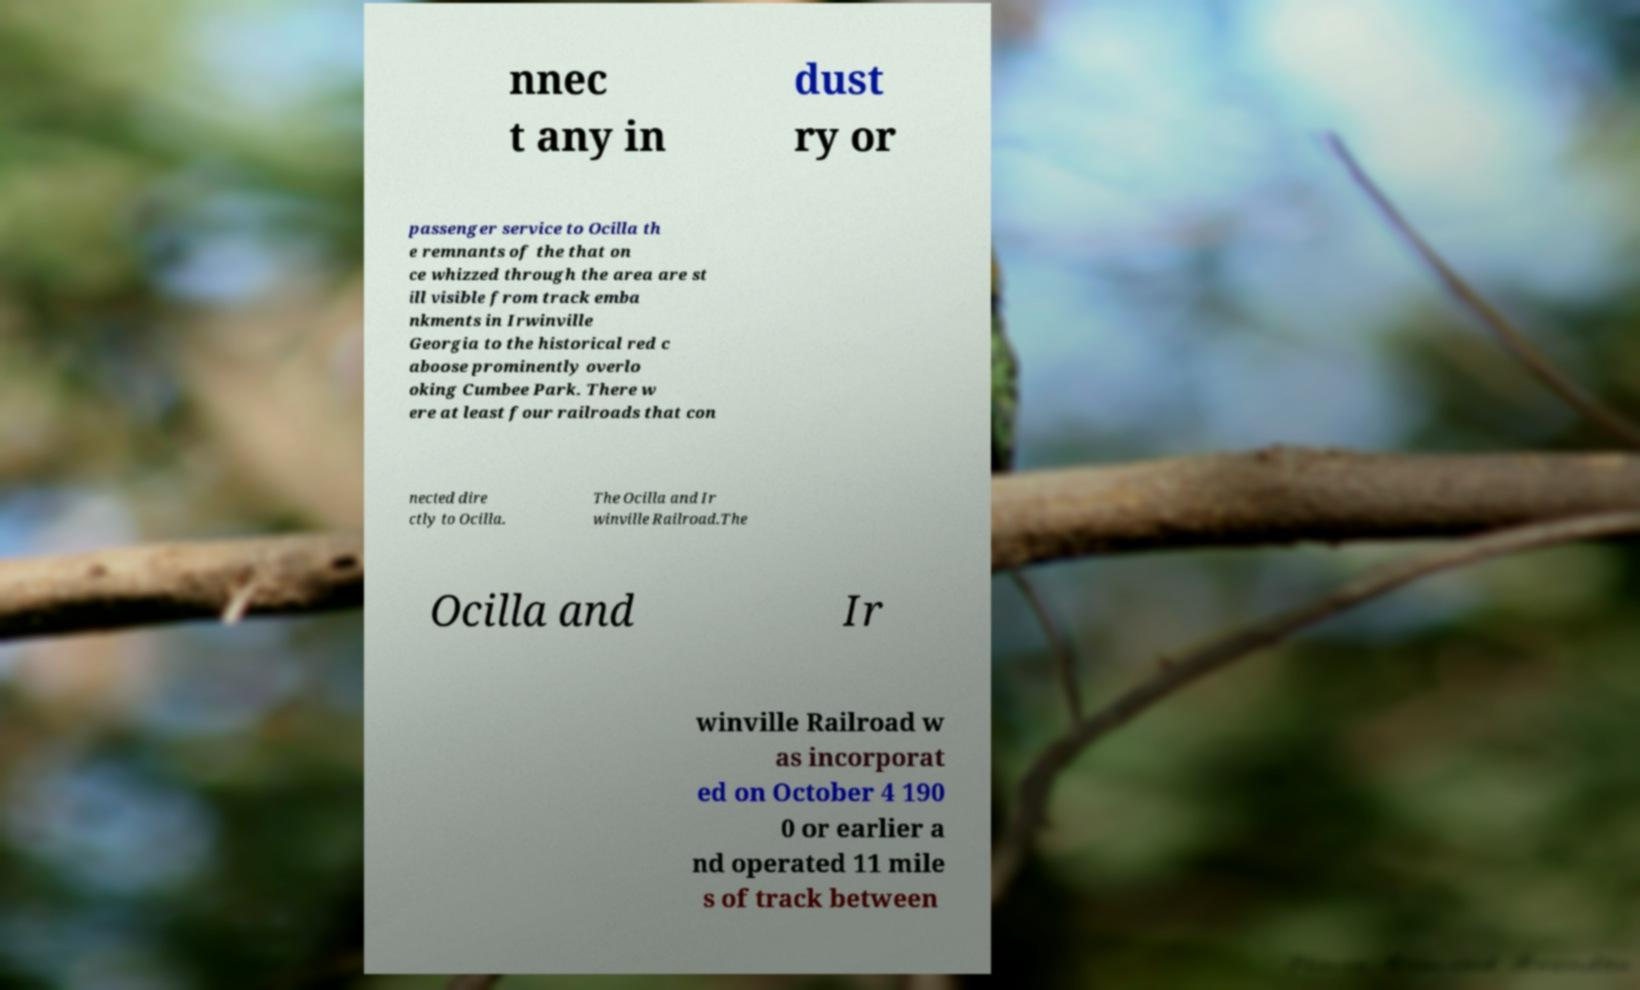Could you extract and type out the text from this image? nnec t any in dust ry or passenger service to Ocilla th e remnants of the that on ce whizzed through the area are st ill visible from track emba nkments in Irwinville Georgia to the historical red c aboose prominently overlo oking Cumbee Park. There w ere at least four railroads that con nected dire ctly to Ocilla. The Ocilla and Ir winville Railroad.The Ocilla and Ir winville Railroad w as incorporat ed on October 4 190 0 or earlier a nd operated 11 mile s of track between 